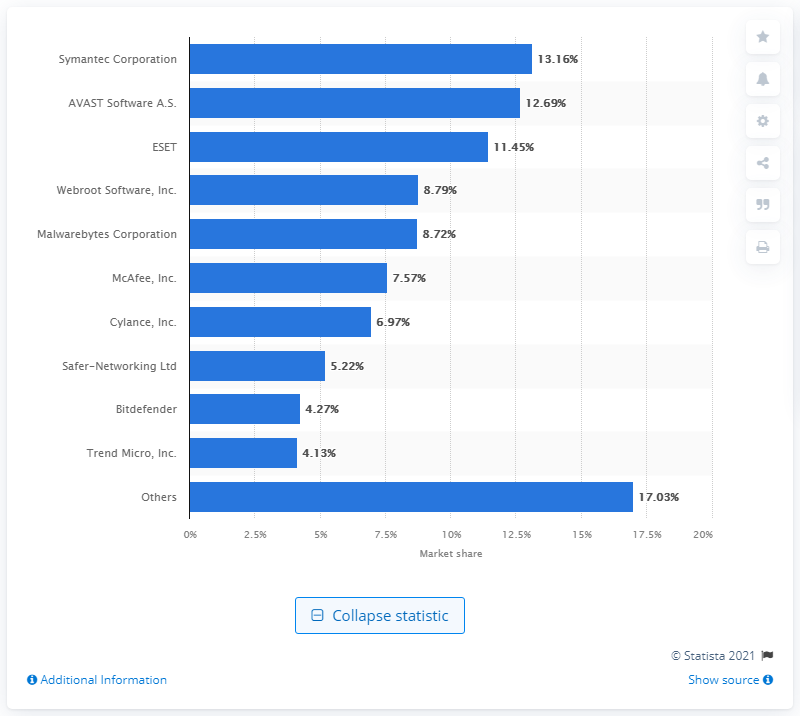Draw attention to some important aspects in this diagram. In May 2020, Symantec Corporation held 13.16% of the Windows anti-malware application market. 